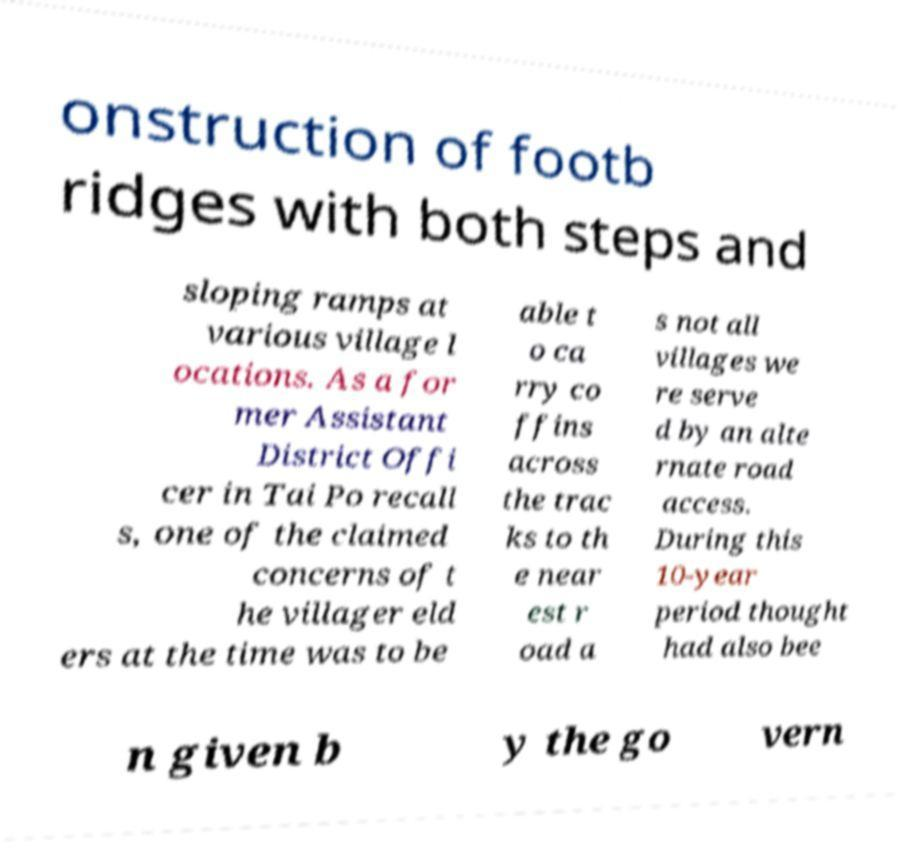Could you extract and type out the text from this image? onstruction of footb ridges with both steps and sloping ramps at various village l ocations. As a for mer Assistant District Offi cer in Tai Po recall s, one of the claimed concerns of t he villager eld ers at the time was to be able t o ca rry co ffins across the trac ks to th e near est r oad a s not all villages we re serve d by an alte rnate road access. During this 10-year period thought had also bee n given b y the go vern 